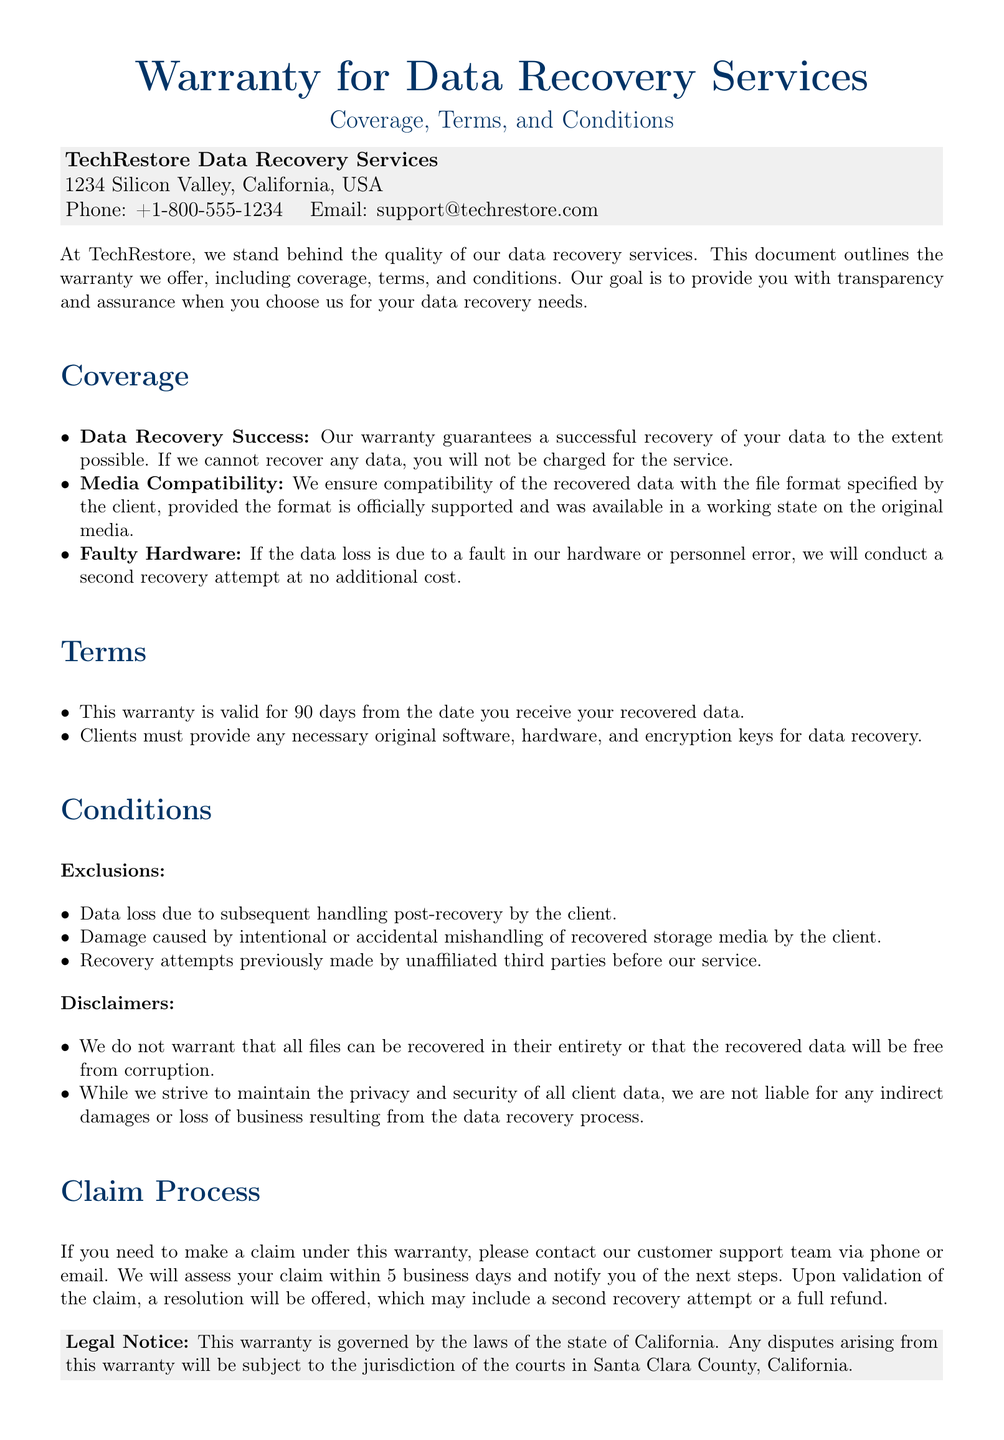What is the company name? The company name is mentioned at the top of the document as TechRestore.
Answer: TechRestore How long is the warranty valid? The document states that the warranty is valid for 90 days from the date you receive your recovered data.
Answer: 90 days What should clients provide for data recovery? The document specifies that clients must provide any necessary original software, hardware, and encryption keys for data recovery.
Answer: Original software, hardware, and encryption keys What happens if data loss is due to client mishandling? In the document, it states that data loss due to subsequent handling by the client is an exclusion under the conditions.
Answer: Exclusion How can a client make a claim? The document mentions that clients should contact customer support via phone or email to make a claim under the warranty.
Answer: Phone or email What is covered under "Faulty Hardware"? The warranty guarantees a second recovery attempt at no additional cost if the data loss is due to a fault in hardware or personnel error.
Answer: Second recovery attempt What is the address of TechRestore? The address is provided in the document as 1234 Silicon Valley, California, USA.
Answer: 1234 Silicon Valley, California, USA What is the legal jurisdiction for disputes? The document states that any disputes arising from the warranty will be subject to the jurisdiction of the courts in Santa Clara County, California.
Answer: Santa Clara County, California 